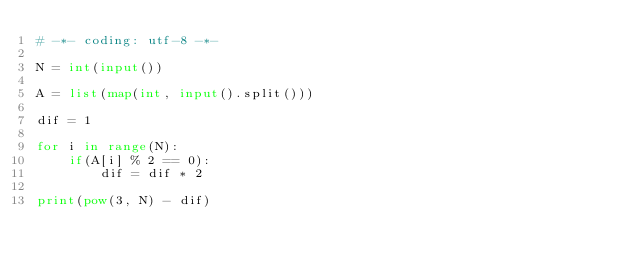Convert code to text. <code><loc_0><loc_0><loc_500><loc_500><_Python_># -*- coding: utf-8 -*-

N = int(input())

A = list(map(int, input().split()))

dif = 1

for i in range(N):
    if(A[i] % 2 == 0):
        dif = dif * 2

print(pow(3, N) - dif)</code> 